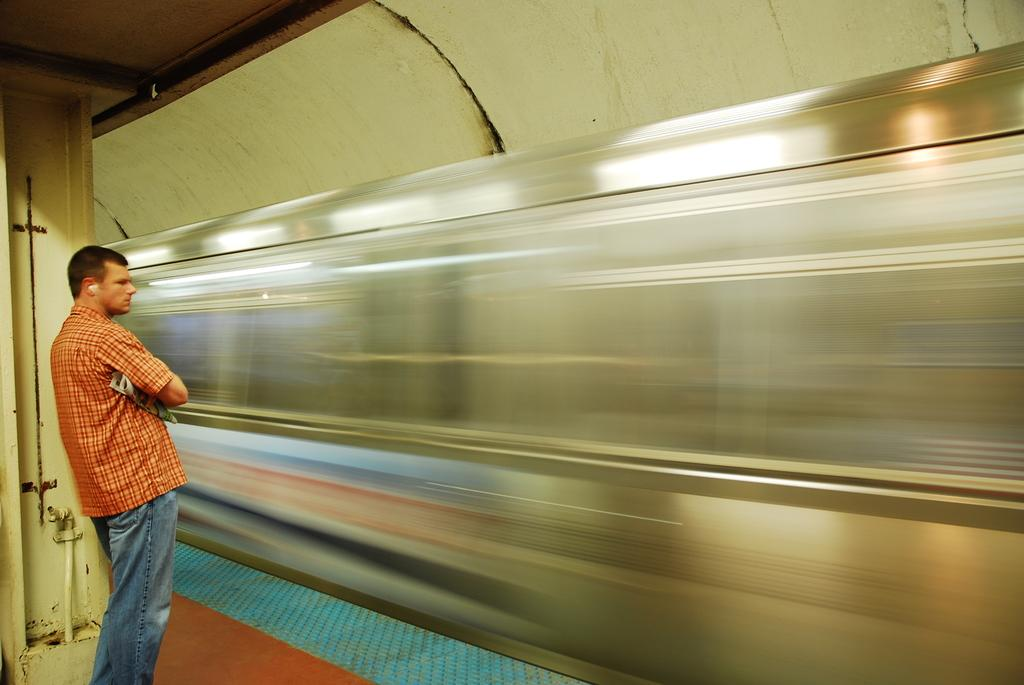What is the main subject of the image? There is a man standing in the image. What is the man wearing? The man is wearing a shirt and jeans. What can be seen in the background of the image? There is a train and a wall in the image. Are there any other objects or elements in the image? Yes, there are other objects in the image. Where is the faucet located in the image? There is no faucet present in the image. What type of table is visible in the image? There is no table present in the image. 